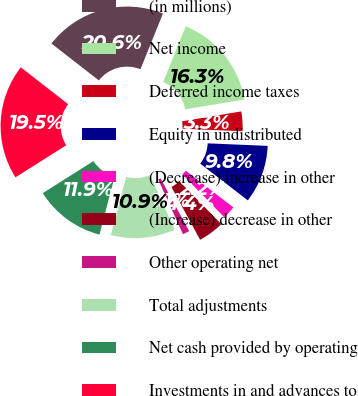<chart> <loc_0><loc_0><loc_500><loc_500><pie_chart><fcel>(in millions)<fcel>Net income<fcel>Deferred income taxes<fcel>Equity in undistributed<fcel>(Decrease) increase in other<fcel>(Increase) decrease in other<fcel>Other operating net<fcel>Total adjustments<fcel>Net cash provided by operating<fcel>Investments in and advances to<nl><fcel>20.58%<fcel>16.26%<fcel>3.31%<fcel>9.78%<fcel>2.23%<fcel>4.39%<fcel>1.15%<fcel>10.86%<fcel>11.94%<fcel>19.5%<nl></chart> 